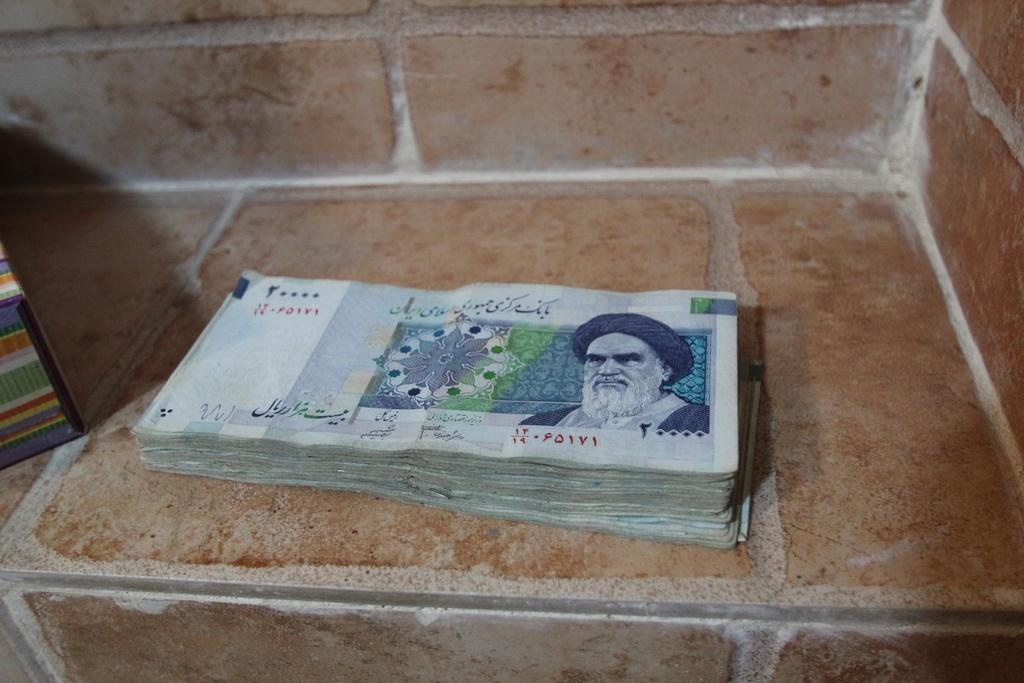What type of items are visible in the image? There are currency notes in the image. What surface are the currency notes placed on? The currency notes are kept on marble stone tiles. Are there any mittens visible in the image? No, there are no mittens present in the image. Can you hear any sounds, such as crying, in the image? The image is silent, and there is no indication of any sounds or crying. 